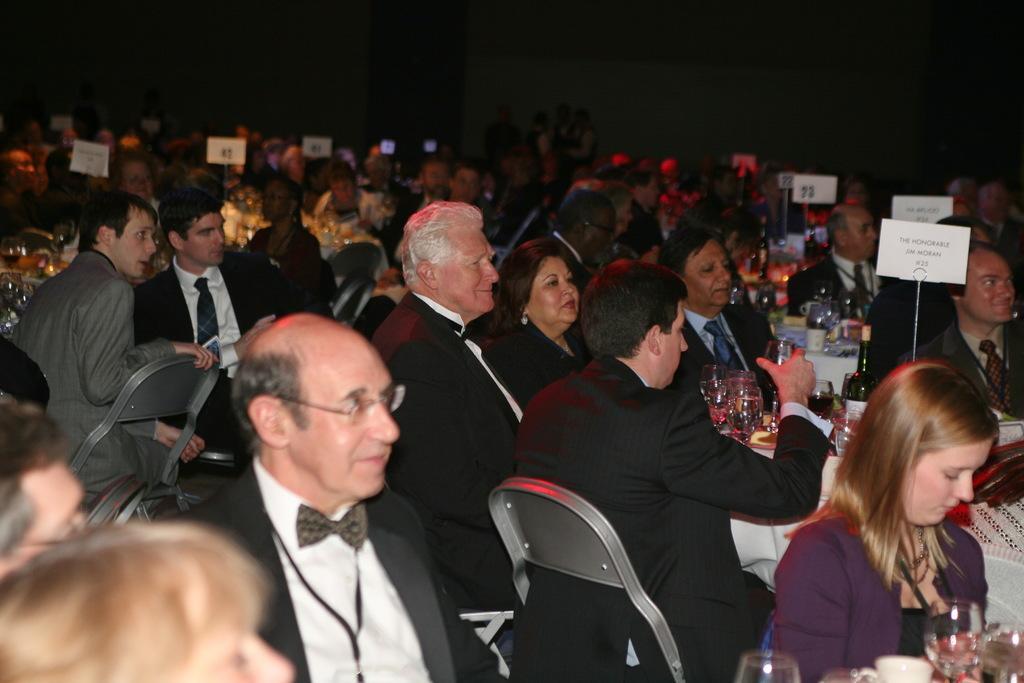Can you describe this image briefly? In this image we can see many people sitting on chairs. There are tables. On the tables there are glasses, bottles and many other items. Also there are papers and something written on that. In the background it is dark. 